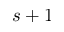<formula> <loc_0><loc_0><loc_500><loc_500>s + 1</formula> 